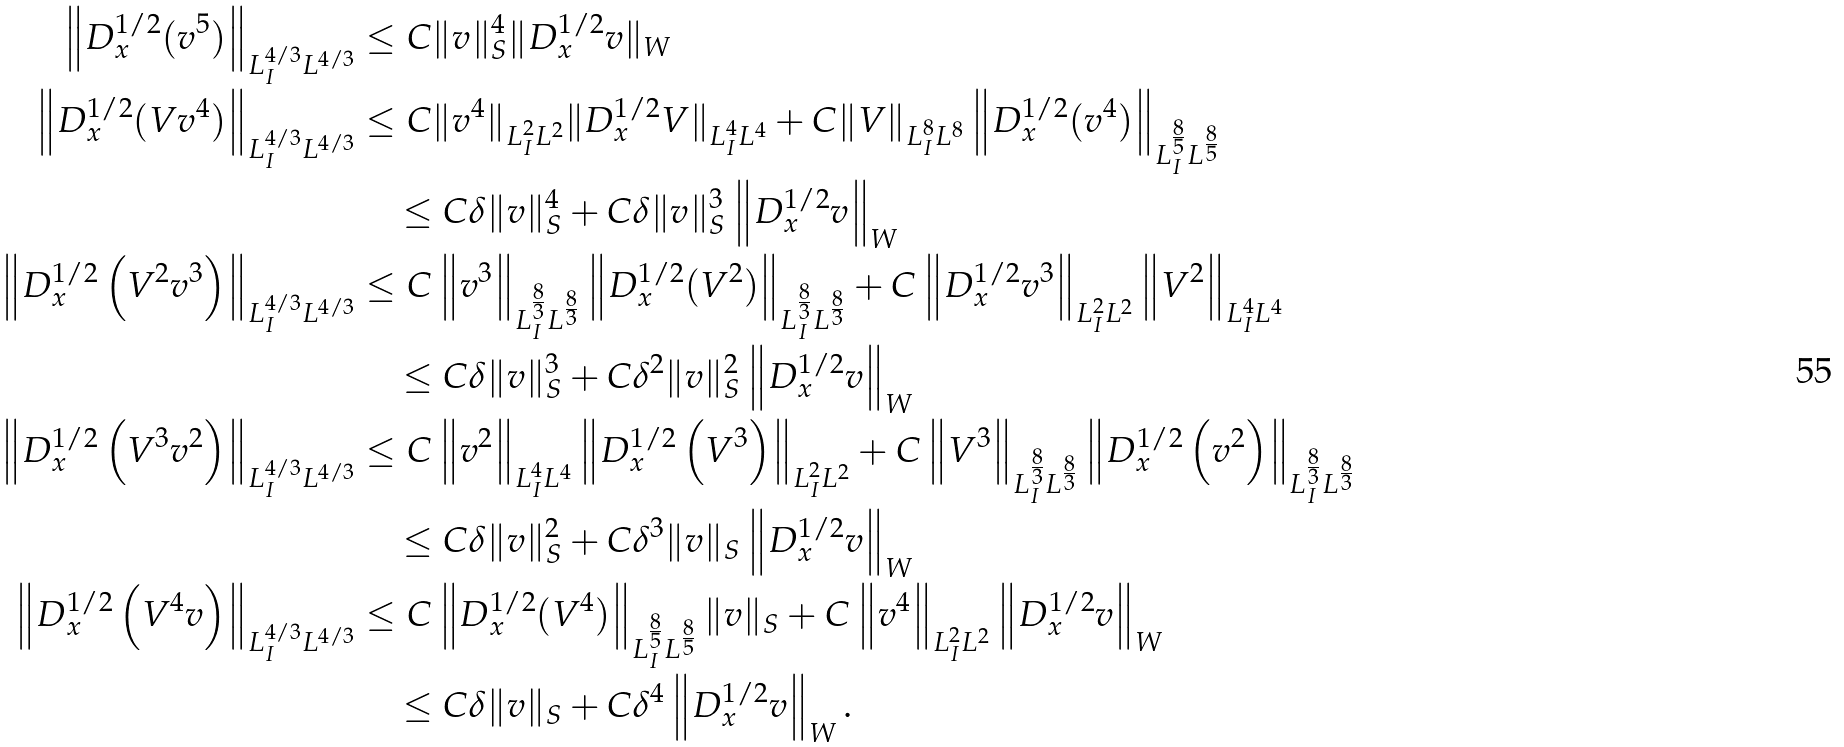<formula> <loc_0><loc_0><loc_500><loc_500>\left \| D _ { x } ^ { 1 / 2 } ( v ^ { 5 } ) \right \| _ { L ^ { 4 / 3 } _ { I } L ^ { 4 / 3 } } & \leq C \| v \| ^ { 4 } _ { S } \| D ^ { 1 / 2 } _ { x } v \| _ { W } \\ \left \| D _ { x } ^ { 1 / 2 } ( V v ^ { 4 } ) \right \| _ { L ^ { 4 / 3 } _ { I } L ^ { 4 / 3 } } & \leq C \| v ^ { 4 } \| _ { L ^ { 2 } _ { I } L ^ { 2 } } \| D ^ { 1 / 2 } _ { x } V \| _ { L ^ { 4 } _ { I } L ^ { 4 } } + C \| V \| _ { L ^ { 8 } _ { I } L ^ { 8 } } \left \| D _ { x } ^ { 1 / 2 } ( v ^ { 4 } ) \right \| _ { L ^ { \frac { 8 } { 5 } } _ { I } L ^ { \frac { 8 } { 5 } } } \\ & \quad \leq C \delta \| v \| _ { S } ^ { 4 } + C \delta \| v \| ^ { 3 } _ { S } \left \| D ^ { 1 / 2 } _ { x } v \right \| _ { W } \\ \left \| D _ { x } ^ { 1 / 2 } \left ( V ^ { 2 } v ^ { 3 } \right ) \right \| _ { L ^ { 4 / 3 } _ { I } L ^ { 4 / 3 } } & \leq C \left \| v ^ { 3 } \right \| _ { L ^ { \frac { 8 } { 3 } } _ { I } L ^ { \frac { 8 } { 3 } } } \left \| D _ { x } ^ { 1 / 2 } ( V ^ { 2 } ) \right \| _ { L ^ { \frac { 8 } { 3 } } _ { I } L ^ { \frac { 8 } { 3 } } } + C \left \| D _ { x } ^ { 1 / 2 } v ^ { 3 } \right \| _ { L ^ { 2 } _ { I } L ^ { 2 } } \left \| V ^ { 2 } \right \| _ { L ^ { 4 } _ { I } L ^ { 4 } } \\ & \quad \leq C \delta \| v \| ^ { 3 } _ { S } + C \delta ^ { 2 } \| v \| ^ { 2 } _ { S } \left \| D ^ { 1 / 2 } _ { x } v \right \| _ { W } \\ \left \| D _ { x } ^ { 1 / 2 } \left ( V ^ { 3 } v ^ { 2 } \right ) \right \| _ { L ^ { 4 / 3 } _ { I } L ^ { 4 / 3 } } & \leq C \left \| v ^ { 2 } \right \| _ { L ^ { 4 } _ { I } L ^ { 4 } } \left \| D _ { x } ^ { 1 / 2 } \left ( V ^ { 3 } \right ) \right \| _ { L ^ { 2 } _ { I } L ^ { 2 } } + C \left \| V ^ { 3 } \right \| _ { L ^ { \frac { 8 } { 3 } } _ { I } L ^ { \frac { 8 } { 3 } } } \left \| D _ { x } ^ { 1 / 2 } \left ( v ^ { 2 } \right ) \right \| _ { L ^ { \frac { 8 } { 3 } } _ { I } L ^ { \frac { 8 } { 3 } } } \\ & \quad \leq C \delta \| v \| ^ { 2 } _ { S } + C \delta ^ { 3 } \| v \| _ { S } \left \| D ^ { 1 / 2 } _ { x } v \right \| _ { W } \\ \left \| D ^ { 1 / 2 } _ { x } \left ( V ^ { 4 } v \right ) \right \| _ { L ^ { 4 / 3 } _ { I } L ^ { 4 / 3 } } & \leq C \left \| D _ { x } ^ { 1 / 2 } ( V ^ { 4 } ) \right \| _ { L ^ { \frac { 8 } { 5 } } _ { I } L ^ { \frac { 8 } { 5 } } } \| v \| _ { S } + C \left \| v ^ { 4 } \right \| _ { L ^ { 2 } _ { I } L ^ { 2 } } \left \| D _ { x } ^ { 1 / 2 } v \right \| _ { W } \\ & \quad \leq C \delta \| v \| _ { S } + C \delta ^ { 4 } \left \| D _ { x } ^ { 1 / 2 } v \right \| _ { W } .</formula> 